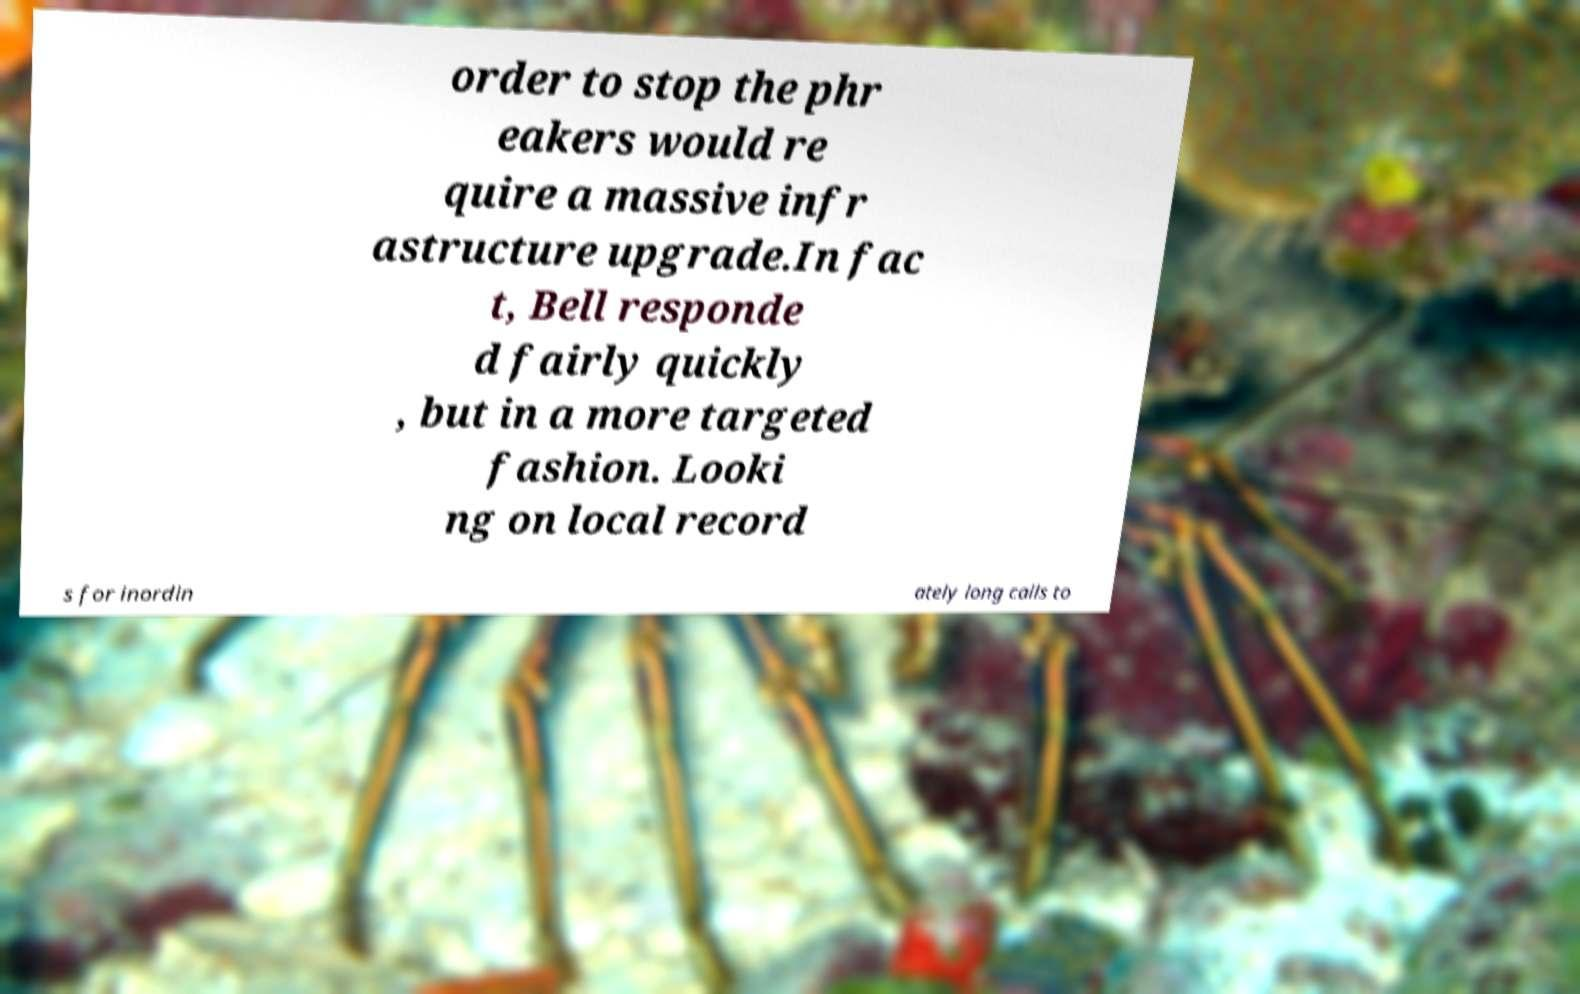What messages or text are displayed in this image? I need them in a readable, typed format. order to stop the phr eakers would re quire a massive infr astructure upgrade.In fac t, Bell responde d fairly quickly , but in a more targeted fashion. Looki ng on local record s for inordin ately long calls to 